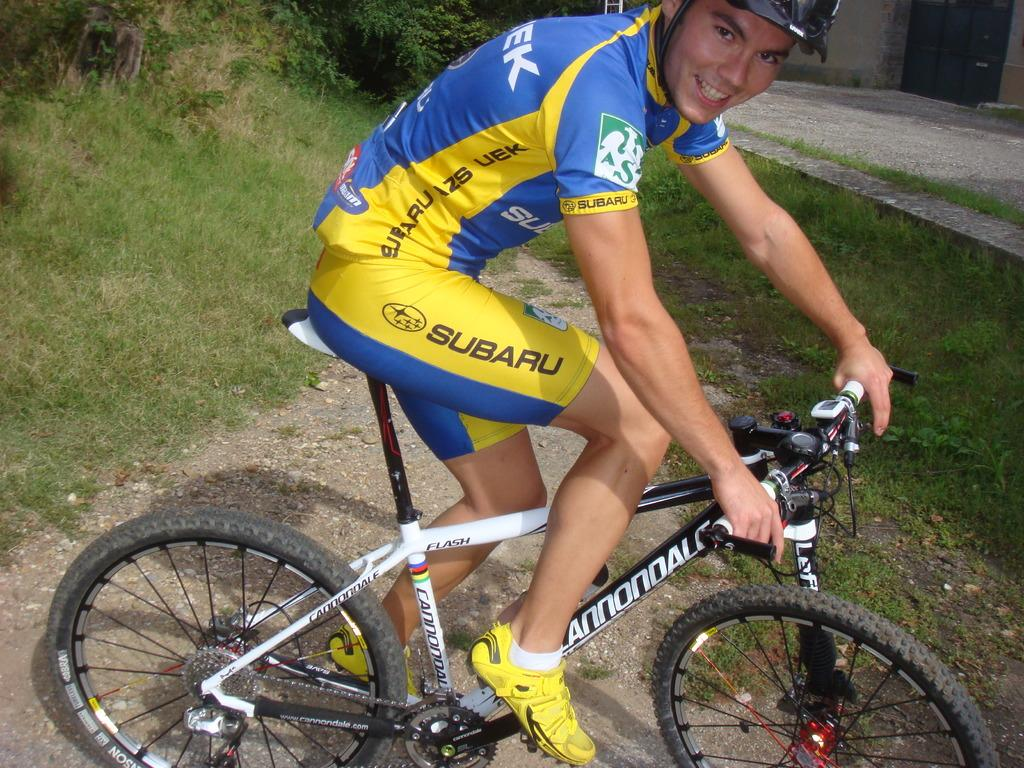Who is present in the image? There is a man in the image. What is the man wearing on his head? The man is wearing a helmet. What is the man sitting on in the image? The man is sitting on a bicycle. What can be seen in the background of the image? There are trees and a path visible in the background of the image. What color is the yarn used to knit the man's sweater in the image? There is no sweater visible in the image, and the man is not wearing yarn. 